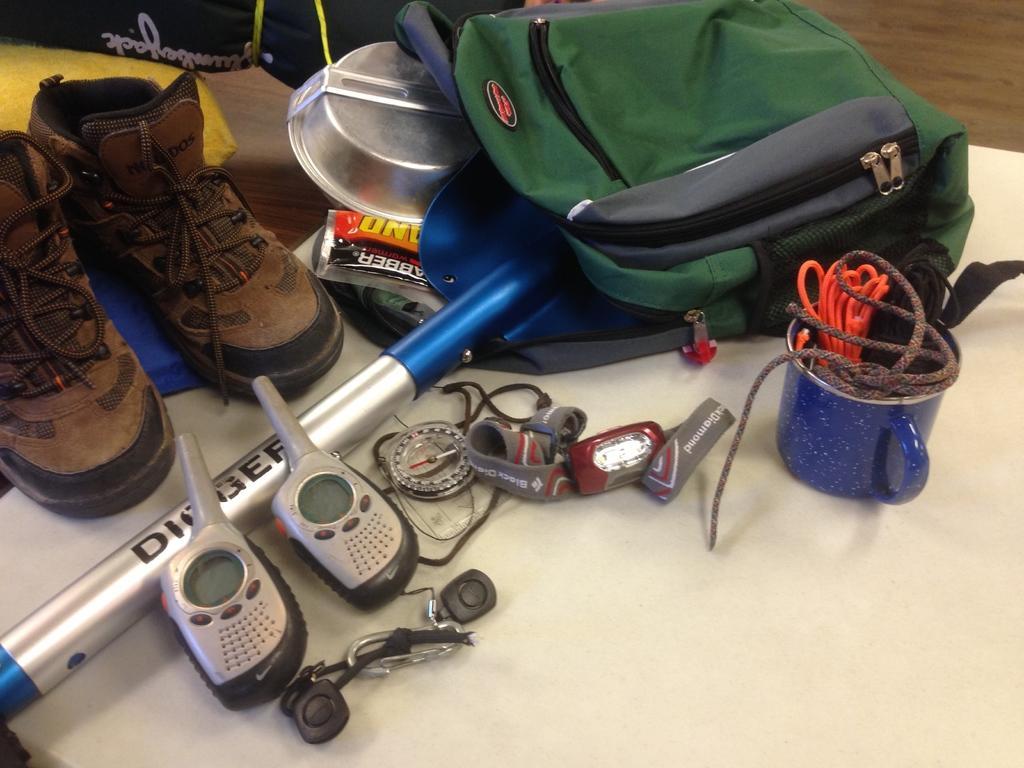Could you give a brief overview of what you see in this image? In this image in front there are shoes, bags, cup, threads, two walkie talkies and few other objects on the table. 